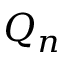<formula> <loc_0><loc_0><loc_500><loc_500>Q _ { n }</formula> 